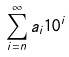<formula> <loc_0><loc_0><loc_500><loc_500>\sum _ { i = n } ^ { \infty } a _ { i } 1 0 ^ { i }</formula> 